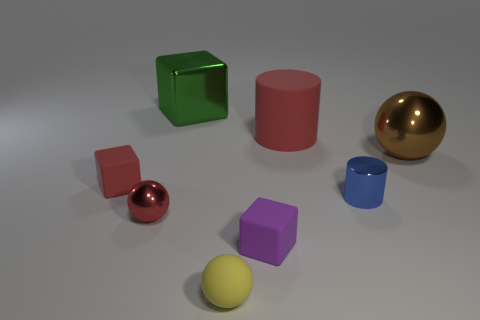Add 2 tiny brown blocks. How many objects exist? 10 Subtract all metallic spheres. How many spheres are left? 1 Subtract all red cylinders. How many cylinders are left? 1 Subtract 1 cylinders. How many cylinders are left? 1 Subtract all brown cylinders. Subtract all yellow balls. How many cylinders are left? 2 Subtract all cyan cylinders. How many green blocks are left? 1 Subtract all brown metallic spheres. Subtract all purple blocks. How many objects are left? 6 Add 7 big cylinders. How many big cylinders are left? 8 Add 6 small red matte cubes. How many small red matte cubes exist? 7 Subtract 0 brown cylinders. How many objects are left? 8 